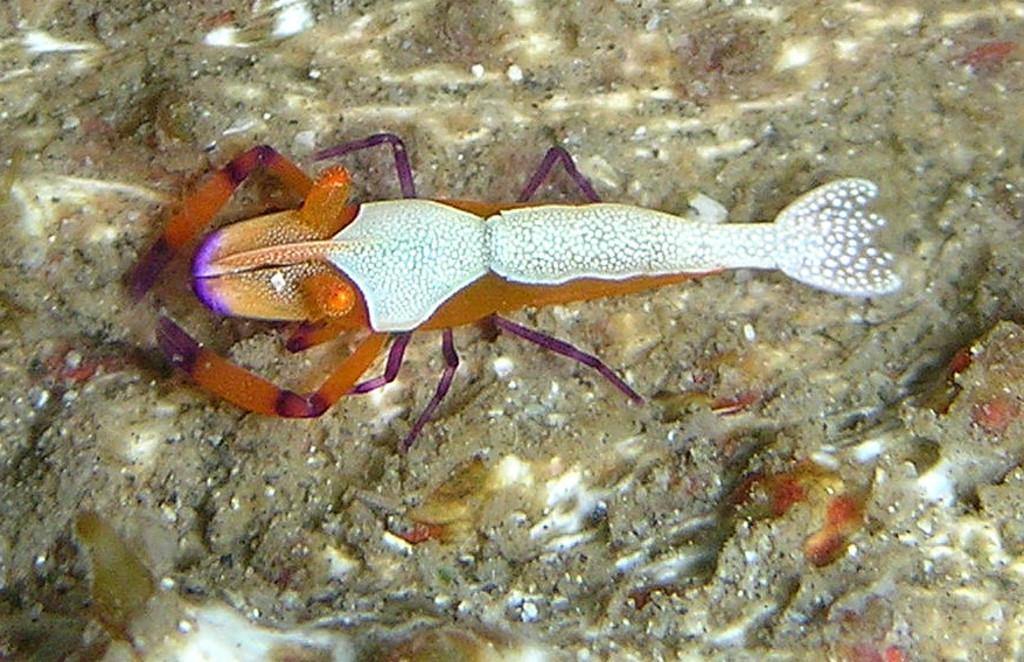What type of environment is the living organism in? The living organism is in water. What colors can be seen on the living organism? The living organism has white and orange colors. What type of pie is being served at the station in the image? There is no pie or station present in the image; it features a living organism in water with white and orange colors. 